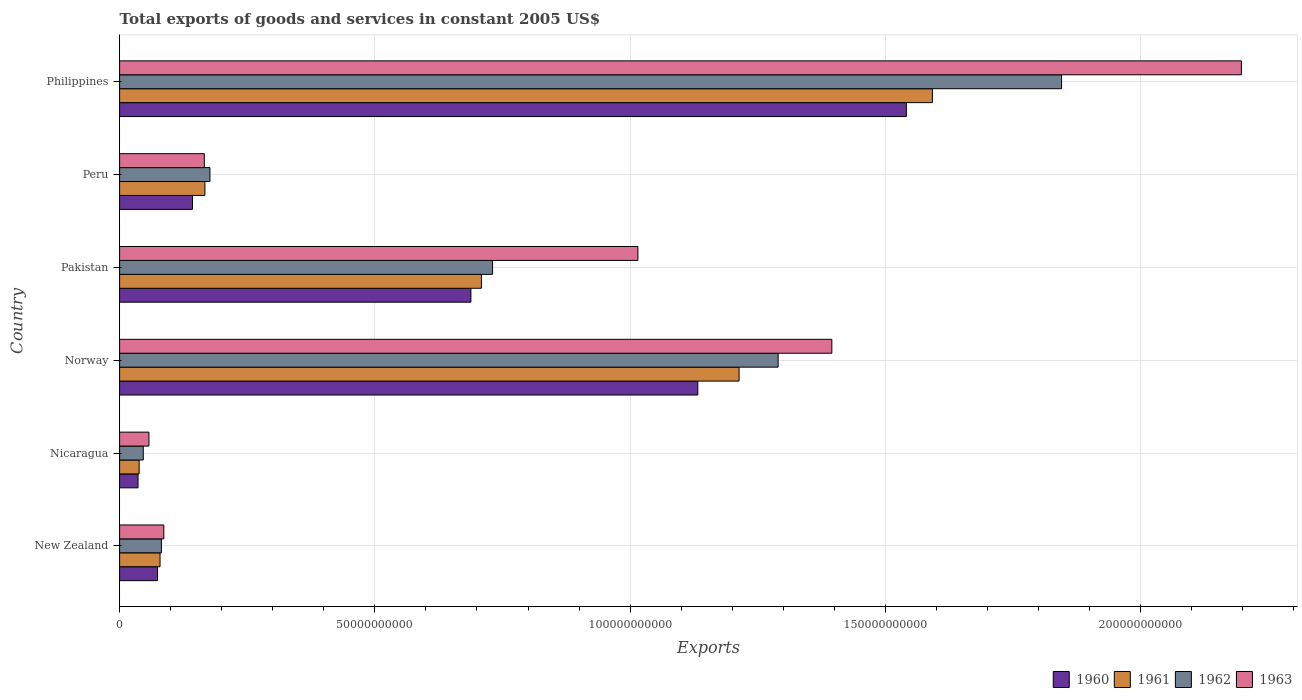How many groups of bars are there?
Provide a short and direct response. 6. Are the number of bars on each tick of the Y-axis equal?
Ensure brevity in your answer.  Yes. How many bars are there on the 4th tick from the top?
Offer a very short reply. 4. How many bars are there on the 6th tick from the bottom?
Make the answer very short. 4. What is the label of the 5th group of bars from the top?
Provide a succinct answer. Nicaragua. What is the total exports of goods and services in 1961 in Philippines?
Your response must be concise. 1.59e+11. Across all countries, what is the maximum total exports of goods and services in 1962?
Your answer should be compact. 1.85e+11. Across all countries, what is the minimum total exports of goods and services in 1962?
Give a very brief answer. 4.64e+09. In which country was the total exports of goods and services in 1963 maximum?
Ensure brevity in your answer.  Philippines. In which country was the total exports of goods and services in 1960 minimum?
Offer a very short reply. Nicaragua. What is the total total exports of goods and services in 1963 in the graph?
Your response must be concise. 4.92e+11. What is the difference between the total exports of goods and services in 1962 in New Zealand and that in Nicaragua?
Ensure brevity in your answer.  3.55e+09. What is the difference between the total exports of goods and services in 1960 in Peru and the total exports of goods and services in 1962 in Norway?
Your answer should be compact. -1.15e+11. What is the average total exports of goods and services in 1961 per country?
Your answer should be compact. 6.33e+1. What is the difference between the total exports of goods and services in 1960 and total exports of goods and services in 1963 in Peru?
Your answer should be very brief. -2.32e+09. What is the ratio of the total exports of goods and services in 1961 in New Zealand to that in Pakistan?
Offer a very short reply. 0.11. Is the total exports of goods and services in 1960 in Norway less than that in Peru?
Offer a terse response. No. What is the difference between the highest and the second highest total exports of goods and services in 1963?
Make the answer very short. 8.02e+1. What is the difference between the highest and the lowest total exports of goods and services in 1963?
Provide a short and direct response. 2.14e+11. In how many countries, is the total exports of goods and services in 1961 greater than the average total exports of goods and services in 1961 taken over all countries?
Your answer should be compact. 3. What does the 4th bar from the top in Pakistan represents?
Make the answer very short. 1960. Is it the case that in every country, the sum of the total exports of goods and services in 1962 and total exports of goods and services in 1963 is greater than the total exports of goods and services in 1960?
Your response must be concise. Yes. Are the values on the major ticks of X-axis written in scientific E-notation?
Ensure brevity in your answer.  No. Does the graph contain any zero values?
Your answer should be compact. No. Does the graph contain grids?
Ensure brevity in your answer.  Yes. Where does the legend appear in the graph?
Offer a very short reply. Bottom right. How many legend labels are there?
Ensure brevity in your answer.  4. What is the title of the graph?
Offer a very short reply. Total exports of goods and services in constant 2005 US$. What is the label or title of the X-axis?
Your answer should be compact. Exports. What is the Exports of 1960 in New Zealand?
Provide a short and direct response. 7.43e+09. What is the Exports in 1961 in New Zealand?
Give a very brief answer. 7.92e+09. What is the Exports in 1962 in New Zealand?
Your response must be concise. 8.19e+09. What is the Exports in 1963 in New Zealand?
Ensure brevity in your answer.  8.66e+09. What is the Exports of 1960 in Nicaragua?
Your response must be concise. 3.61e+09. What is the Exports of 1961 in Nicaragua?
Provide a succinct answer. 3.83e+09. What is the Exports of 1962 in Nicaragua?
Make the answer very short. 4.64e+09. What is the Exports of 1963 in Nicaragua?
Provide a succinct answer. 5.74e+09. What is the Exports in 1960 in Norway?
Provide a short and direct response. 1.13e+11. What is the Exports in 1961 in Norway?
Your answer should be compact. 1.21e+11. What is the Exports in 1962 in Norway?
Offer a very short reply. 1.29e+11. What is the Exports of 1963 in Norway?
Your answer should be compact. 1.40e+11. What is the Exports of 1960 in Pakistan?
Offer a terse response. 6.88e+1. What is the Exports of 1961 in Pakistan?
Your answer should be compact. 7.09e+1. What is the Exports of 1962 in Pakistan?
Provide a short and direct response. 7.31e+1. What is the Exports of 1963 in Pakistan?
Offer a very short reply. 1.02e+11. What is the Exports of 1960 in Peru?
Offer a very short reply. 1.43e+1. What is the Exports in 1961 in Peru?
Offer a very short reply. 1.67e+1. What is the Exports in 1962 in Peru?
Provide a succinct answer. 1.77e+1. What is the Exports of 1963 in Peru?
Provide a short and direct response. 1.66e+1. What is the Exports of 1960 in Philippines?
Keep it short and to the point. 1.54e+11. What is the Exports in 1961 in Philippines?
Provide a short and direct response. 1.59e+11. What is the Exports of 1962 in Philippines?
Your answer should be very brief. 1.85e+11. What is the Exports of 1963 in Philippines?
Offer a very short reply. 2.20e+11. Across all countries, what is the maximum Exports in 1960?
Your response must be concise. 1.54e+11. Across all countries, what is the maximum Exports in 1961?
Offer a very short reply. 1.59e+11. Across all countries, what is the maximum Exports of 1962?
Make the answer very short. 1.85e+11. Across all countries, what is the maximum Exports in 1963?
Provide a succinct answer. 2.20e+11. Across all countries, what is the minimum Exports of 1960?
Make the answer very short. 3.61e+09. Across all countries, what is the minimum Exports in 1961?
Make the answer very short. 3.83e+09. Across all countries, what is the minimum Exports in 1962?
Offer a very short reply. 4.64e+09. Across all countries, what is the minimum Exports in 1963?
Provide a succinct answer. 5.74e+09. What is the total Exports of 1960 in the graph?
Offer a terse response. 3.61e+11. What is the total Exports of 1961 in the graph?
Offer a terse response. 3.80e+11. What is the total Exports in 1962 in the graph?
Offer a terse response. 4.17e+11. What is the total Exports in 1963 in the graph?
Provide a short and direct response. 4.92e+11. What is the difference between the Exports of 1960 in New Zealand and that in Nicaragua?
Your response must be concise. 3.82e+09. What is the difference between the Exports in 1961 in New Zealand and that in Nicaragua?
Offer a very short reply. 4.10e+09. What is the difference between the Exports of 1962 in New Zealand and that in Nicaragua?
Make the answer very short. 3.55e+09. What is the difference between the Exports of 1963 in New Zealand and that in Nicaragua?
Ensure brevity in your answer.  2.92e+09. What is the difference between the Exports of 1960 in New Zealand and that in Norway?
Provide a short and direct response. -1.06e+11. What is the difference between the Exports in 1961 in New Zealand and that in Norway?
Your answer should be very brief. -1.13e+11. What is the difference between the Exports in 1962 in New Zealand and that in Norway?
Offer a very short reply. -1.21e+11. What is the difference between the Exports in 1963 in New Zealand and that in Norway?
Your answer should be very brief. -1.31e+11. What is the difference between the Exports in 1960 in New Zealand and that in Pakistan?
Your response must be concise. -6.14e+1. What is the difference between the Exports in 1961 in New Zealand and that in Pakistan?
Provide a short and direct response. -6.29e+1. What is the difference between the Exports in 1962 in New Zealand and that in Pakistan?
Your answer should be compact. -6.49e+1. What is the difference between the Exports in 1963 in New Zealand and that in Pakistan?
Provide a succinct answer. -9.29e+1. What is the difference between the Exports in 1960 in New Zealand and that in Peru?
Offer a terse response. -6.85e+09. What is the difference between the Exports of 1961 in New Zealand and that in Peru?
Keep it short and to the point. -8.79e+09. What is the difference between the Exports in 1962 in New Zealand and that in Peru?
Ensure brevity in your answer.  -9.50e+09. What is the difference between the Exports of 1963 in New Zealand and that in Peru?
Give a very brief answer. -7.94e+09. What is the difference between the Exports in 1960 in New Zealand and that in Philippines?
Your answer should be compact. -1.47e+11. What is the difference between the Exports of 1961 in New Zealand and that in Philippines?
Provide a succinct answer. -1.51e+11. What is the difference between the Exports in 1962 in New Zealand and that in Philippines?
Ensure brevity in your answer.  -1.76e+11. What is the difference between the Exports in 1963 in New Zealand and that in Philippines?
Keep it short and to the point. -2.11e+11. What is the difference between the Exports of 1960 in Nicaragua and that in Norway?
Provide a succinct answer. -1.10e+11. What is the difference between the Exports of 1961 in Nicaragua and that in Norway?
Make the answer very short. -1.18e+11. What is the difference between the Exports in 1962 in Nicaragua and that in Norway?
Provide a succinct answer. -1.24e+11. What is the difference between the Exports in 1963 in Nicaragua and that in Norway?
Provide a short and direct response. -1.34e+11. What is the difference between the Exports of 1960 in Nicaragua and that in Pakistan?
Make the answer very short. -6.52e+1. What is the difference between the Exports in 1961 in Nicaragua and that in Pakistan?
Offer a terse response. -6.70e+1. What is the difference between the Exports in 1962 in Nicaragua and that in Pakistan?
Provide a succinct answer. -6.84e+1. What is the difference between the Exports in 1963 in Nicaragua and that in Pakistan?
Make the answer very short. -9.58e+1. What is the difference between the Exports in 1960 in Nicaragua and that in Peru?
Offer a very short reply. -1.07e+1. What is the difference between the Exports of 1961 in Nicaragua and that in Peru?
Provide a short and direct response. -1.29e+1. What is the difference between the Exports of 1962 in Nicaragua and that in Peru?
Give a very brief answer. -1.31e+1. What is the difference between the Exports in 1963 in Nicaragua and that in Peru?
Your answer should be compact. -1.09e+1. What is the difference between the Exports of 1960 in Nicaragua and that in Philippines?
Keep it short and to the point. -1.50e+11. What is the difference between the Exports in 1961 in Nicaragua and that in Philippines?
Offer a very short reply. -1.55e+11. What is the difference between the Exports in 1962 in Nicaragua and that in Philippines?
Keep it short and to the point. -1.80e+11. What is the difference between the Exports in 1963 in Nicaragua and that in Philippines?
Your answer should be very brief. -2.14e+11. What is the difference between the Exports of 1960 in Norway and that in Pakistan?
Provide a short and direct response. 4.44e+1. What is the difference between the Exports of 1961 in Norway and that in Pakistan?
Make the answer very short. 5.05e+1. What is the difference between the Exports in 1962 in Norway and that in Pakistan?
Your answer should be very brief. 5.59e+1. What is the difference between the Exports in 1963 in Norway and that in Pakistan?
Provide a succinct answer. 3.80e+1. What is the difference between the Exports in 1960 in Norway and that in Peru?
Your response must be concise. 9.90e+1. What is the difference between the Exports in 1961 in Norway and that in Peru?
Give a very brief answer. 1.05e+11. What is the difference between the Exports in 1962 in Norway and that in Peru?
Give a very brief answer. 1.11e+11. What is the difference between the Exports of 1963 in Norway and that in Peru?
Provide a short and direct response. 1.23e+11. What is the difference between the Exports of 1960 in Norway and that in Philippines?
Keep it short and to the point. -4.09e+1. What is the difference between the Exports of 1961 in Norway and that in Philippines?
Your answer should be compact. -3.79e+1. What is the difference between the Exports in 1962 in Norway and that in Philippines?
Ensure brevity in your answer.  -5.55e+1. What is the difference between the Exports of 1963 in Norway and that in Philippines?
Keep it short and to the point. -8.02e+1. What is the difference between the Exports in 1960 in Pakistan and that in Peru?
Keep it short and to the point. 5.45e+1. What is the difference between the Exports of 1961 in Pakistan and that in Peru?
Your answer should be compact. 5.42e+1. What is the difference between the Exports of 1962 in Pakistan and that in Peru?
Your answer should be very brief. 5.54e+1. What is the difference between the Exports of 1963 in Pakistan and that in Peru?
Your answer should be compact. 8.49e+1. What is the difference between the Exports in 1960 in Pakistan and that in Philippines?
Provide a succinct answer. -8.53e+1. What is the difference between the Exports of 1961 in Pakistan and that in Philippines?
Keep it short and to the point. -8.83e+1. What is the difference between the Exports in 1962 in Pakistan and that in Philippines?
Give a very brief answer. -1.11e+11. What is the difference between the Exports of 1963 in Pakistan and that in Philippines?
Your answer should be very brief. -1.18e+11. What is the difference between the Exports of 1960 in Peru and that in Philippines?
Provide a succinct answer. -1.40e+11. What is the difference between the Exports in 1961 in Peru and that in Philippines?
Provide a succinct answer. -1.42e+11. What is the difference between the Exports in 1962 in Peru and that in Philippines?
Ensure brevity in your answer.  -1.67e+11. What is the difference between the Exports in 1963 in Peru and that in Philippines?
Your response must be concise. -2.03e+11. What is the difference between the Exports in 1960 in New Zealand and the Exports in 1961 in Nicaragua?
Your response must be concise. 3.60e+09. What is the difference between the Exports in 1960 in New Zealand and the Exports in 1962 in Nicaragua?
Offer a very short reply. 2.79e+09. What is the difference between the Exports in 1960 in New Zealand and the Exports in 1963 in Nicaragua?
Provide a short and direct response. 1.68e+09. What is the difference between the Exports in 1961 in New Zealand and the Exports in 1962 in Nicaragua?
Provide a succinct answer. 3.29e+09. What is the difference between the Exports in 1961 in New Zealand and the Exports in 1963 in Nicaragua?
Offer a very short reply. 2.18e+09. What is the difference between the Exports of 1962 in New Zealand and the Exports of 1963 in Nicaragua?
Give a very brief answer. 2.45e+09. What is the difference between the Exports of 1960 in New Zealand and the Exports of 1961 in Norway?
Give a very brief answer. -1.14e+11. What is the difference between the Exports of 1960 in New Zealand and the Exports of 1962 in Norway?
Keep it short and to the point. -1.22e+11. What is the difference between the Exports of 1960 in New Zealand and the Exports of 1963 in Norway?
Provide a short and direct response. -1.32e+11. What is the difference between the Exports in 1961 in New Zealand and the Exports in 1962 in Norway?
Offer a terse response. -1.21e+11. What is the difference between the Exports of 1961 in New Zealand and the Exports of 1963 in Norway?
Give a very brief answer. -1.32e+11. What is the difference between the Exports of 1962 in New Zealand and the Exports of 1963 in Norway?
Your answer should be very brief. -1.31e+11. What is the difference between the Exports in 1960 in New Zealand and the Exports in 1961 in Pakistan?
Your response must be concise. -6.34e+1. What is the difference between the Exports of 1960 in New Zealand and the Exports of 1962 in Pakistan?
Your response must be concise. -6.56e+1. What is the difference between the Exports in 1960 in New Zealand and the Exports in 1963 in Pakistan?
Provide a short and direct response. -9.41e+1. What is the difference between the Exports of 1961 in New Zealand and the Exports of 1962 in Pakistan?
Give a very brief answer. -6.51e+1. What is the difference between the Exports in 1961 in New Zealand and the Exports in 1963 in Pakistan?
Your answer should be very brief. -9.36e+1. What is the difference between the Exports of 1962 in New Zealand and the Exports of 1963 in Pakistan?
Provide a succinct answer. -9.33e+1. What is the difference between the Exports in 1960 in New Zealand and the Exports in 1961 in Peru?
Provide a succinct answer. -9.28e+09. What is the difference between the Exports in 1960 in New Zealand and the Exports in 1962 in Peru?
Your response must be concise. -1.03e+1. What is the difference between the Exports in 1960 in New Zealand and the Exports in 1963 in Peru?
Your answer should be compact. -9.17e+09. What is the difference between the Exports of 1961 in New Zealand and the Exports of 1962 in Peru?
Your answer should be compact. -9.77e+09. What is the difference between the Exports of 1961 in New Zealand and the Exports of 1963 in Peru?
Provide a succinct answer. -8.67e+09. What is the difference between the Exports in 1962 in New Zealand and the Exports in 1963 in Peru?
Your answer should be compact. -8.40e+09. What is the difference between the Exports of 1960 in New Zealand and the Exports of 1961 in Philippines?
Ensure brevity in your answer.  -1.52e+11. What is the difference between the Exports of 1960 in New Zealand and the Exports of 1962 in Philippines?
Provide a succinct answer. -1.77e+11. What is the difference between the Exports of 1960 in New Zealand and the Exports of 1963 in Philippines?
Your response must be concise. -2.12e+11. What is the difference between the Exports of 1961 in New Zealand and the Exports of 1962 in Philippines?
Your answer should be compact. -1.77e+11. What is the difference between the Exports in 1961 in New Zealand and the Exports in 1963 in Philippines?
Your answer should be very brief. -2.12e+11. What is the difference between the Exports in 1962 in New Zealand and the Exports in 1963 in Philippines?
Your response must be concise. -2.12e+11. What is the difference between the Exports of 1960 in Nicaragua and the Exports of 1961 in Norway?
Provide a short and direct response. -1.18e+11. What is the difference between the Exports of 1960 in Nicaragua and the Exports of 1962 in Norway?
Give a very brief answer. -1.25e+11. What is the difference between the Exports of 1960 in Nicaragua and the Exports of 1963 in Norway?
Your response must be concise. -1.36e+11. What is the difference between the Exports in 1961 in Nicaragua and the Exports in 1962 in Norway?
Your answer should be compact. -1.25e+11. What is the difference between the Exports in 1961 in Nicaragua and the Exports in 1963 in Norway?
Provide a short and direct response. -1.36e+11. What is the difference between the Exports in 1962 in Nicaragua and the Exports in 1963 in Norway?
Offer a very short reply. -1.35e+11. What is the difference between the Exports in 1960 in Nicaragua and the Exports in 1961 in Pakistan?
Your answer should be very brief. -6.73e+1. What is the difference between the Exports of 1960 in Nicaragua and the Exports of 1962 in Pakistan?
Provide a succinct answer. -6.94e+1. What is the difference between the Exports of 1960 in Nicaragua and the Exports of 1963 in Pakistan?
Give a very brief answer. -9.79e+1. What is the difference between the Exports of 1961 in Nicaragua and the Exports of 1962 in Pakistan?
Give a very brief answer. -6.92e+1. What is the difference between the Exports of 1961 in Nicaragua and the Exports of 1963 in Pakistan?
Make the answer very short. -9.77e+1. What is the difference between the Exports in 1962 in Nicaragua and the Exports in 1963 in Pakistan?
Keep it short and to the point. -9.69e+1. What is the difference between the Exports in 1960 in Nicaragua and the Exports in 1961 in Peru?
Keep it short and to the point. -1.31e+1. What is the difference between the Exports of 1960 in Nicaragua and the Exports of 1962 in Peru?
Your response must be concise. -1.41e+1. What is the difference between the Exports in 1960 in Nicaragua and the Exports in 1963 in Peru?
Give a very brief answer. -1.30e+1. What is the difference between the Exports of 1961 in Nicaragua and the Exports of 1962 in Peru?
Give a very brief answer. -1.39e+1. What is the difference between the Exports of 1961 in Nicaragua and the Exports of 1963 in Peru?
Your answer should be compact. -1.28e+1. What is the difference between the Exports in 1962 in Nicaragua and the Exports in 1963 in Peru?
Your answer should be compact. -1.20e+1. What is the difference between the Exports in 1960 in Nicaragua and the Exports in 1961 in Philippines?
Offer a very short reply. -1.56e+11. What is the difference between the Exports in 1960 in Nicaragua and the Exports in 1962 in Philippines?
Provide a succinct answer. -1.81e+11. What is the difference between the Exports of 1960 in Nicaragua and the Exports of 1963 in Philippines?
Provide a succinct answer. -2.16e+11. What is the difference between the Exports of 1961 in Nicaragua and the Exports of 1962 in Philippines?
Give a very brief answer. -1.81e+11. What is the difference between the Exports in 1961 in Nicaragua and the Exports in 1963 in Philippines?
Give a very brief answer. -2.16e+11. What is the difference between the Exports of 1962 in Nicaragua and the Exports of 1963 in Philippines?
Ensure brevity in your answer.  -2.15e+11. What is the difference between the Exports of 1960 in Norway and the Exports of 1961 in Pakistan?
Keep it short and to the point. 4.24e+1. What is the difference between the Exports in 1960 in Norway and the Exports in 1962 in Pakistan?
Your answer should be compact. 4.02e+1. What is the difference between the Exports in 1960 in Norway and the Exports in 1963 in Pakistan?
Give a very brief answer. 1.17e+1. What is the difference between the Exports of 1961 in Norway and the Exports of 1962 in Pakistan?
Provide a short and direct response. 4.83e+1. What is the difference between the Exports in 1961 in Norway and the Exports in 1963 in Pakistan?
Make the answer very short. 1.98e+1. What is the difference between the Exports in 1962 in Norway and the Exports in 1963 in Pakistan?
Offer a terse response. 2.75e+1. What is the difference between the Exports in 1960 in Norway and the Exports in 1961 in Peru?
Your answer should be very brief. 9.65e+1. What is the difference between the Exports in 1960 in Norway and the Exports in 1962 in Peru?
Provide a succinct answer. 9.56e+1. What is the difference between the Exports in 1960 in Norway and the Exports in 1963 in Peru?
Your response must be concise. 9.67e+1. What is the difference between the Exports in 1961 in Norway and the Exports in 1962 in Peru?
Your response must be concise. 1.04e+11. What is the difference between the Exports of 1961 in Norway and the Exports of 1963 in Peru?
Provide a short and direct response. 1.05e+11. What is the difference between the Exports of 1962 in Norway and the Exports of 1963 in Peru?
Your answer should be very brief. 1.12e+11. What is the difference between the Exports in 1960 in Norway and the Exports in 1961 in Philippines?
Provide a succinct answer. -4.59e+1. What is the difference between the Exports of 1960 in Norway and the Exports of 1962 in Philippines?
Your answer should be compact. -7.12e+1. What is the difference between the Exports of 1960 in Norway and the Exports of 1963 in Philippines?
Ensure brevity in your answer.  -1.06e+11. What is the difference between the Exports of 1961 in Norway and the Exports of 1962 in Philippines?
Give a very brief answer. -6.32e+1. What is the difference between the Exports in 1961 in Norway and the Exports in 1963 in Philippines?
Ensure brevity in your answer.  -9.84e+1. What is the difference between the Exports of 1962 in Norway and the Exports of 1963 in Philippines?
Your response must be concise. -9.07e+1. What is the difference between the Exports of 1960 in Pakistan and the Exports of 1961 in Peru?
Provide a short and direct response. 5.21e+1. What is the difference between the Exports of 1960 in Pakistan and the Exports of 1962 in Peru?
Your response must be concise. 5.11e+1. What is the difference between the Exports of 1960 in Pakistan and the Exports of 1963 in Peru?
Your response must be concise. 5.22e+1. What is the difference between the Exports in 1961 in Pakistan and the Exports in 1962 in Peru?
Your response must be concise. 5.32e+1. What is the difference between the Exports in 1961 in Pakistan and the Exports in 1963 in Peru?
Ensure brevity in your answer.  5.43e+1. What is the difference between the Exports of 1962 in Pakistan and the Exports of 1963 in Peru?
Keep it short and to the point. 5.65e+1. What is the difference between the Exports of 1960 in Pakistan and the Exports of 1961 in Philippines?
Your response must be concise. -9.04e+1. What is the difference between the Exports of 1960 in Pakistan and the Exports of 1962 in Philippines?
Your response must be concise. -1.16e+11. What is the difference between the Exports in 1960 in Pakistan and the Exports in 1963 in Philippines?
Provide a short and direct response. -1.51e+11. What is the difference between the Exports in 1961 in Pakistan and the Exports in 1962 in Philippines?
Your answer should be very brief. -1.14e+11. What is the difference between the Exports of 1961 in Pakistan and the Exports of 1963 in Philippines?
Provide a short and direct response. -1.49e+11. What is the difference between the Exports in 1962 in Pakistan and the Exports in 1963 in Philippines?
Provide a succinct answer. -1.47e+11. What is the difference between the Exports of 1960 in Peru and the Exports of 1961 in Philippines?
Provide a succinct answer. -1.45e+11. What is the difference between the Exports of 1960 in Peru and the Exports of 1962 in Philippines?
Your answer should be very brief. -1.70e+11. What is the difference between the Exports of 1960 in Peru and the Exports of 1963 in Philippines?
Give a very brief answer. -2.05e+11. What is the difference between the Exports in 1961 in Peru and the Exports in 1962 in Philippines?
Provide a short and direct response. -1.68e+11. What is the difference between the Exports of 1961 in Peru and the Exports of 1963 in Philippines?
Your answer should be very brief. -2.03e+11. What is the difference between the Exports in 1962 in Peru and the Exports in 1963 in Philippines?
Provide a succinct answer. -2.02e+11. What is the average Exports of 1960 per country?
Offer a terse response. 6.02e+1. What is the average Exports in 1961 per country?
Your answer should be compact. 6.33e+1. What is the average Exports of 1962 per country?
Offer a very short reply. 6.95e+1. What is the average Exports in 1963 per country?
Give a very brief answer. 8.20e+1. What is the difference between the Exports of 1960 and Exports of 1961 in New Zealand?
Offer a terse response. -4.96e+08. What is the difference between the Exports of 1960 and Exports of 1962 in New Zealand?
Give a very brief answer. -7.63e+08. What is the difference between the Exports of 1960 and Exports of 1963 in New Zealand?
Your response must be concise. -1.23e+09. What is the difference between the Exports in 1961 and Exports in 1962 in New Zealand?
Your response must be concise. -2.67e+08. What is the difference between the Exports of 1961 and Exports of 1963 in New Zealand?
Keep it short and to the point. -7.36e+08. What is the difference between the Exports in 1962 and Exports in 1963 in New Zealand?
Your answer should be compact. -4.69e+08. What is the difference between the Exports of 1960 and Exports of 1961 in Nicaragua?
Make the answer very short. -2.16e+08. What is the difference between the Exports in 1960 and Exports in 1962 in Nicaragua?
Your answer should be compact. -1.02e+09. What is the difference between the Exports in 1960 and Exports in 1963 in Nicaragua?
Your response must be concise. -2.13e+09. What is the difference between the Exports in 1961 and Exports in 1962 in Nicaragua?
Make the answer very short. -8.09e+08. What is the difference between the Exports of 1961 and Exports of 1963 in Nicaragua?
Offer a very short reply. -1.92e+09. What is the difference between the Exports in 1962 and Exports in 1963 in Nicaragua?
Your answer should be very brief. -1.11e+09. What is the difference between the Exports of 1960 and Exports of 1961 in Norway?
Provide a succinct answer. -8.08e+09. What is the difference between the Exports of 1960 and Exports of 1962 in Norway?
Offer a very short reply. -1.57e+1. What is the difference between the Exports of 1960 and Exports of 1963 in Norway?
Your answer should be very brief. -2.63e+1. What is the difference between the Exports of 1961 and Exports of 1962 in Norway?
Your answer should be compact. -7.65e+09. What is the difference between the Exports of 1961 and Exports of 1963 in Norway?
Your answer should be compact. -1.82e+1. What is the difference between the Exports of 1962 and Exports of 1963 in Norway?
Give a very brief answer. -1.05e+1. What is the difference between the Exports of 1960 and Exports of 1961 in Pakistan?
Keep it short and to the point. -2.06e+09. What is the difference between the Exports of 1960 and Exports of 1962 in Pakistan?
Ensure brevity in your answer.  -4.24e+09. What is the difference between the Exports of 1960 and Exports of 1963 in Pakistan?
Give a very brief answer. -3.27e+1. What is the difference between the Exports of 1961 and Exports of 1962 in Pakistan?
Make the answer very short. -2.18e+09. What is the difference between the Exports of 1961 and Exports of 1963 in Pakistan?
Your response must be concise. -3.06e+1. What is the difference between the Exports of 1962 and Exports of 1963 in Pakistan?
Provide a short and direct response. -2.85e+1. What is the difference between the Exports in 1960 and Exports in 1961 in Peru?
Your answer should be compact. -2.43e+09. What is the difference between the Exports of 1960 and Exports of 1962 in Peru?
Your response must be concise. -3.42e+09. What is the difference between the Exports of 1960 and Exports of 1963 in Peru?
Your answer should be compact. -2.32e+09. What is the difference between the Exports of 1961 and Exports of 1962 in Peru?
Provide a succinct answer. -9.83e+08. What is the difference between the Exports in 1961 and Exports in 1963 in Peru?
Your answer should be compact. 1.16e+08. What is the difference between the Exports in 1962 and Exports in 1963 in Peru?
Ensure brevity in your answer.  1.10e+09. What is the difference between the Exports in 1960 and Exports in 1961 in Philippines?
Ensure brevity in your answer.  -5.10e+09. What is the difference between the Exports in 1960 and Exports in 1962 in Philippines?
Keep it short and to the point. -3.04e+1. What is the difference between the Exports of 1960 and Exports of 1963 in Philippines?
Ensure brevity in your answer.  -6.56e+1. What is the difference between the Exports of 1961 and Exports of 1962 in Philippines?
Offer a terse response. -2.53e+1. What is the difference between the Exports in 1961 and Exports in 1963 in Philippines?
Keep it short and to the point. -6.05e+1. What is the difference between the Exports in 1962 and Exports in 1963 in Philippines?
Ensure brevity in your answer.  -3.52e+1. What is the ratio of the Exports in 1960 in New Zealand to that in Nicaragua?
Your answer should be compact. 2.06. What is the ratio of the Exports of 1961 in New Zealand to that in Nicaragua?
Keep it short and to the point. 2.07. What is the ratio of the Exports of 1962 in New Zealand to that in Nicaragua?
Provide a succinct answer. 1.77. What is the ratio of the Exports in 1963 in New Zealand to that in Nicaragua?
Give a very brief answer. 1.51. What is the ratio of the Exports in 1960 in New Zealand to that in Norway?
Your answer should be very brief. 0.07. What is the ratio of the Exports in 1961 in New Zealand to that in Norway?
Offer a very short reply. 0.07. What is the ratio of the Exports of 1962 in New Zealand to that in Norway?
Provide a succinct answer. 0.06. What is the ratio of the Exports in 1963 in New Zealand to that in Norway?
Make the answer very short. 0.06. What is the ratio of the Exports of 1960 in New Zealand to that in Pakistan?
Give a very brief answer. 0.11. What is the ratio of the Exports of 1961 in New Zealand to that in Pakistan?
Your response must be concise. 0.11. What is the ratio of the Exports in 1962 in New Zealand to that in Pakistan?
Offer a terse response. 0.11. What is the ratio of the Exports of 1963 in New Zealand to that in Pakistan?
Keep it short and to the point. 0.09. What is the ratio of the Exports of 1960 in New Zealand to that in Peru?
Offer a very short reply. 0.52. What is the ratio of the Exports in 1961 in New Zealand to that in Peru?
Provide a short and direct response. 0.47. What is the ratio of the Exports of 1962 in New Zealand to that in Peru?
Your answer should be very brief. 0.46. What is the ratio of the Exports in 1963 in New Zealand to that in Peru?
Provide a short and direct response. 0.52. What is the ratio of the Exports in 1960 in New Zealand to that in Philippines?
Make the answer very short. 0.05. What is the ratio of the Exports of 1961 in New Zealand to that in Philippines?
Give a very brief answer. 0.05. What is the ratio of the Exports in 1962 in New Zealand to that in Philippines?
Give a very brief answer. 0.04. What is the ratio of the Exports in 1963 in New Zealand to that in Philippines?
Ensure brevity in your answer.  0.04. What is the ratio of the Exports in 1960 in Nicaragua to that in Norway?
Ensure brevity in your answer.  0.03. What is the ratio of the Exports in 1961 in Nicaragua to that in Norway?
Offer a terse response. 0.03. What is the ratio of the Exports of 1962 in Nicaragua to that in Norway?
Offer a terse response. 0.04. What is the ratio of the Exports in 1963 in Nicaragua to that in Norway?
Offer a terse response. 0.04. What is the ratio of the Exports in 1960 in Nicaragua to that in Pakistan?
Ensure brevity in your answer.  0.05. What is the ratio of the Exports of 1961 in Nicaragua to that in Pakistan?
Your response must be concise. 0.05. What is the ratio of the Exports in 1962 in Nicaragua to that in Pakistan?
Your response must be concise. 0.06. What is the ratio of the Exports in 1963 in Nicaragua to that in Pakistan?
Provide a short and direct response. 0.06. What is the ratio of the Exports in 1960 in Nicaragua to that in Peru?
Your answer should be very brief. 0.25. What is the ratio of the Exports of 1961 in Nicaragua to that in Peru?
Provide a short and direct response. 0.23. What is the ratio of the Exports in 1962 in Nicaragua to that in Peru?
Give a very brief answer. 0.26. What is the ratio of the Exports of 1963 in Nicaragua to that in Peru?
Your answer should be compact. 0.35. What is the ratio of the Exports in 1960 in Nicaragua to that in Philippines?
Offer a terse response. 0.02. What is the ratio of the Exports in 1961 in Nicaragua to that in Philippines?
Give a very brief answer. 0.02. What is the ratio of the Exports in 1962 in Nicaragua to that in Philippines?
Provide a succinct answer. 0.03. What is the ratio of the Exports of 1963 in Nicaragua to that in Philippines?
Give a very brief answer. 0.03. What is the ratio of the Exports of 1960 in Norway to that in Pakistan?
Give a very brief answer. 1.65. What is the ratio of the Exports of 1961 in Norway to that in Pakistan?
Make the answer very short. 1.71. What is the ratio of the Exports of 1962 in Norway to that in Pakistan?
Your response must be concise. 1.77. What is the ratio of the Exports in 1963 in Norway to that in Pakistan?
Ensure brevity in your answer.  1.37. What is the ratio of the Exports in 1960 in Norway to that in Peru?
Your answer should be very brief. 7.93. What is the ratio of the Exports of 1961 in Norway to that in Peru?
Give a very brief answer. 7.26. What is the ratio of the Exports of 1962 in Norway to that in Peru?
Your answer should be compact. 7.29. What is the ratio of the Exports of 1963 in Norway to that in Peru?
Offer a terse response. 8.41. What is the ratio of the Exports in 1960 in Norway to that in Philippines?
Your answer should be compact. 0.73. What is the ratio of the Exports of 1961 in Norway to that in Philippines?
Offer a terse response. 0.76. What is the ratio of the Exports of 1962 in Norway to that in Philippines?
Keep it short and to the point. 0.7. What is the ratio of the Exports in 1963 in Norway to that in Philippines?
Provide a succinct answer. 0.63. What is the ratio of the Exports in 1960 in Pakistan to that in Peru?
Your answer should be compact. 4.82. What is the ratio of the Exports in 1961 in Pakistan to that in Peru?
Offer a terse response. 4.24. What is the ratio of the Exports in 1962 in Pakistan to that in Peru?
Offer a terse response. 4.13. What is the ratio of the Exports of 1963 in Pakistan to that in Peru?
Provide a succinct answer. 6.12. What is the ratio of the Exports of 1960 in Pakistan to that in Philippines?
Give a very brief answer. 0.45. What is the ratio of the Exports of 1961 in Pakistan to that in Philippines?
Offer a very short reply. 0.45. What is the ratio of the Exports of 1962 in Pakistan to that in Philippines?
Your answer should be very brief. 0.4. What is the ratio of the Exports in 1963 in Pakistan to that in Philippines?
Make the answer very short. 0.46. What is the ratio of the Exports in 1960 in Peru to that in Philippines?
Keep it short and to the point. 0.09. What is the ratio of the Exports of 1961 in Peru to that in Philippines?
Make the answer very short. 0.1. What is the ratio of the Exports in 1962 in Peru to that in Philippines?
Provide a short and direct response. 0.1. What is the ratio of the Exports in 1963 in Peru to that in Philippines?
Your answer should be very brief. 0.08. What is the difference between the highest and the second highest Exports of 1960?
Your response must be concise. 4.09e+1. What is the difference between the highest and the second highest Exports in 1961?
Offer a terse response. 3.79e+1. What is the difference between the highest and the second highest Exports of 1962?
Keep it short and to the point. 5.55e+1. What is the difference between the highest and the second highest Exports in 1963?
Make the answer very short. 8.02e+1. What is the difference between the highest and the lowest Exports in 1960?
Provide a short and direct response. 1.50e+11. What is the difference between the highest and the lowest Exports of 1961?
Your answer should be very brief. 1.55e+11. What is the difference between the highest and the lowest Exports of 1962?
Your answer should be compact. 1.80e+11. What is the difference between the highest and the lowest Exports of 1963?
Make the answer very short. 2.14e+11. 